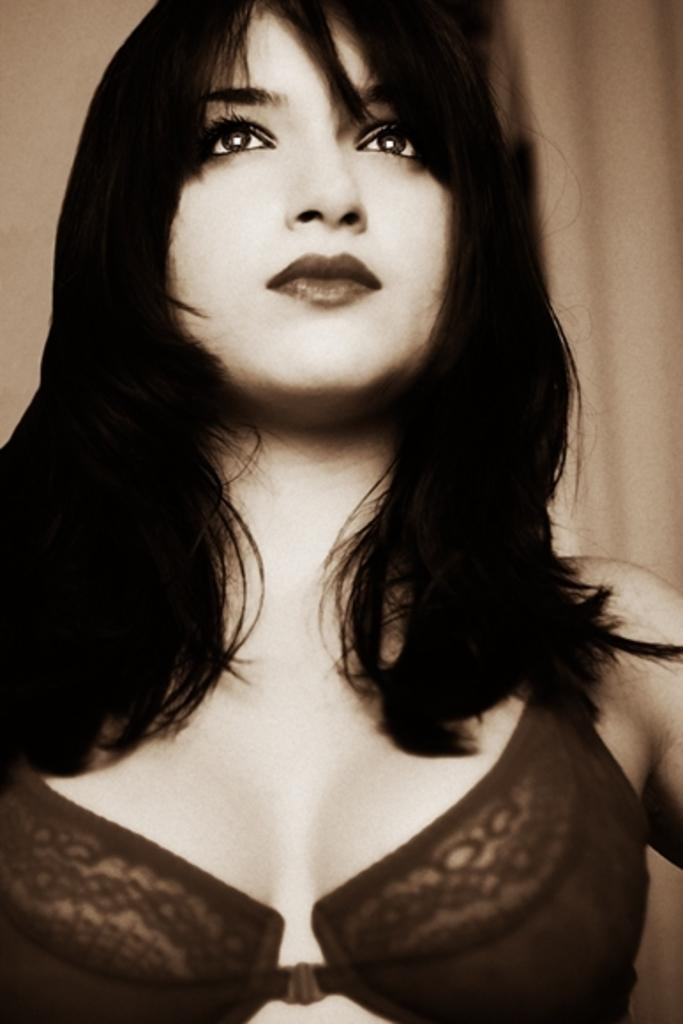Who is present in the image? There is a lady in the image. What can be seen in the background of the image? There is a cloth in the background of the image. What type of meat is being cooked in the image? There is no meat or cooking activity present in the image; it only features a lady and a cloth in the background. 